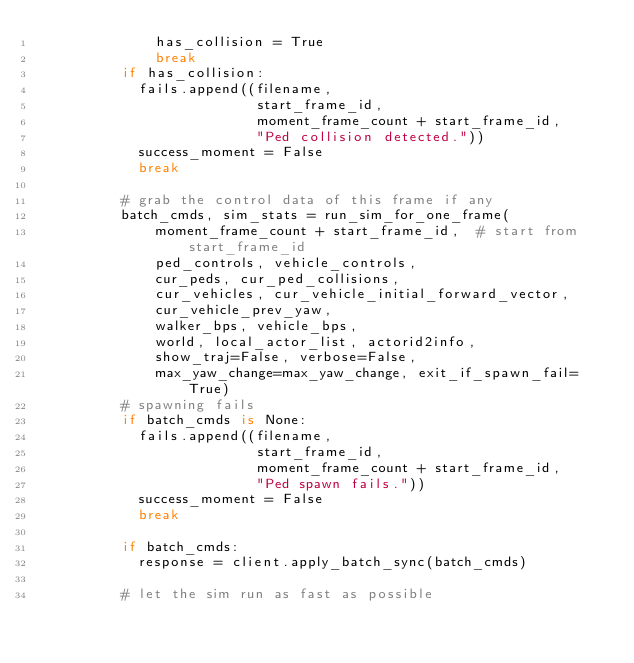Convert code to text. <code><loc_0><loc_0><loc_500><loc_500><_Python_>              has_collision = True
              break
          if has_collision:
            fails.append((filename,
                          start_frame_id,
                          moment_frame_count + start_frame_id,
                          "Ped collision detected."))
            success_moment = False
            break

          # grab the control data of this frame if any
          batch_cmds, sim_stats = run_sim_for_one_frame(
              moment_frame_count + start_frame_id,  # start from start_frame_id
              ped_controls, vehicle_controls,
              cur_peds, cur_ped_collisions,
              cur_vehicles, cur_vehicle_initial_forward_vector,
              cur_vehicle_prev_yaw,
              walker_bps, vehicle_bps,
              world, local_actor_list, actorid2info,
              show_traj=False, verbose=False,
              max_yaw_change=max_yaw_change, exit_if_spawn_fail=True)
          # spawning fails
          if batch_cmds is None:
            fails.append((filename,
                          start_frame_id,
                          moment_frame_count + start_frame_id,
                          "Ped spawn fails."))
            success_moment = False
            break

          if batch_cmds:
            response = client.apply_batch_sync(batch_cmds)

          # let the sim run as fast as possible</code> 